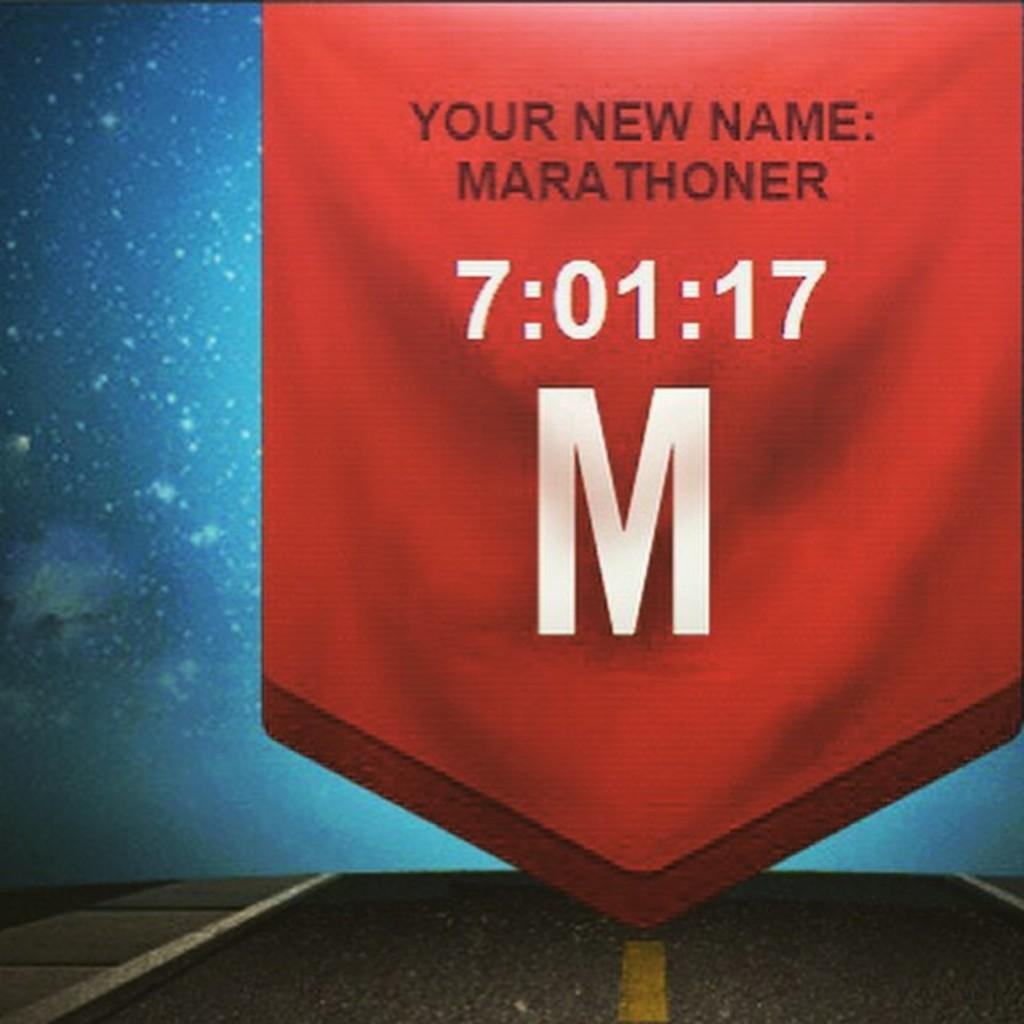<image>
Give a short and clear explanation of the subsequent image. Sign that says "Your new name" and the name Mara Thoner. 